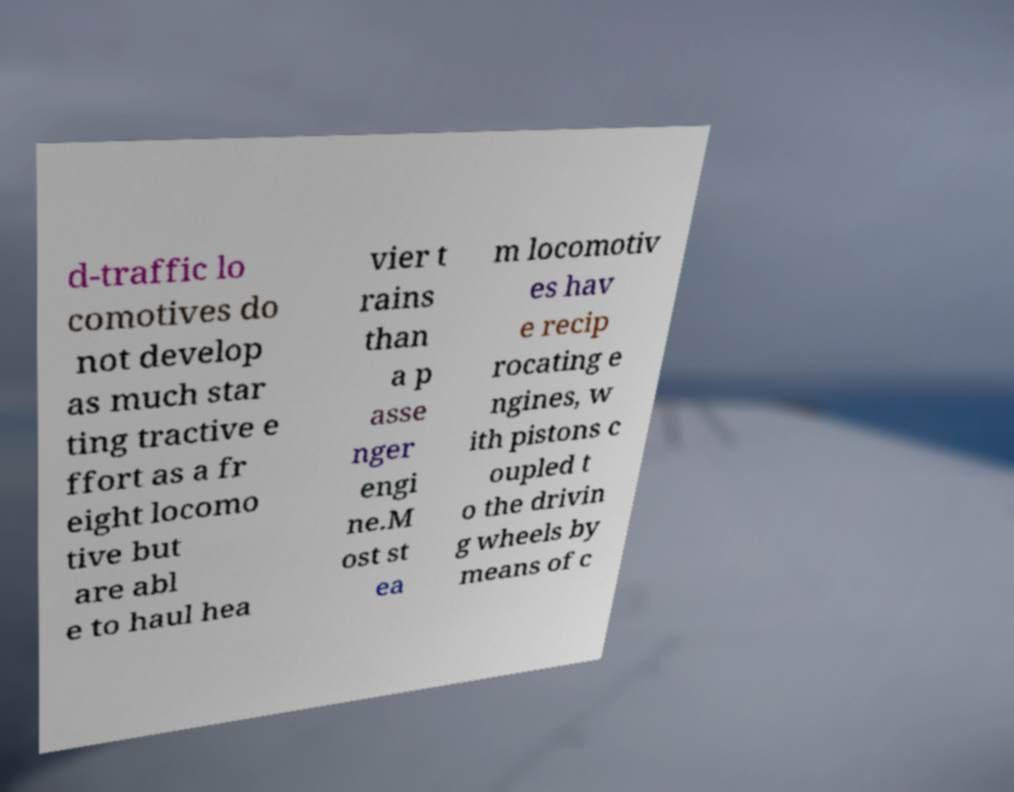Can you accurately transcribe the text from the provided image for me? d-traffic lo comotives do not develop as much star ting tractive e ffort as a fr eight locomo tive but are abl e to haul hea vier t rains than a p asse nger engi ne.M ost st ea m locomotiv es hav e recip rocating e ngines, w ith pistons c oupled t o the drivin g wheels by means of c 